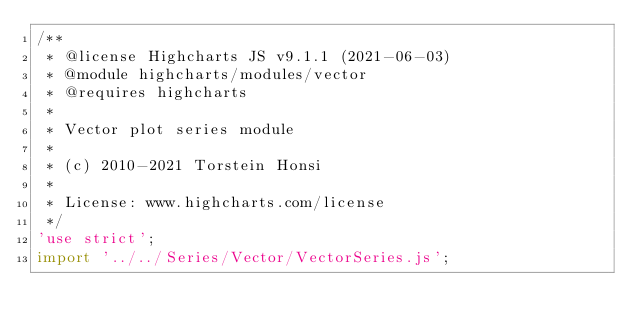Convert code to text. <code><loc_0><loc_0><loc_500><loc_500><_JavaScript_>/**
 * @license Highcharts JS v9.1.1 (2021-06-03)
 * @module highcharts/modules/vector
 * @requires highcharts
 *
 * Vector plot series module
 *
 * (c) 2010-2021 Torstein Honsi
 *
 * License: www.highcharts.com/license
 */
'use strict';
import '../../Series/Vector/VectorSeries.js';
</code> 